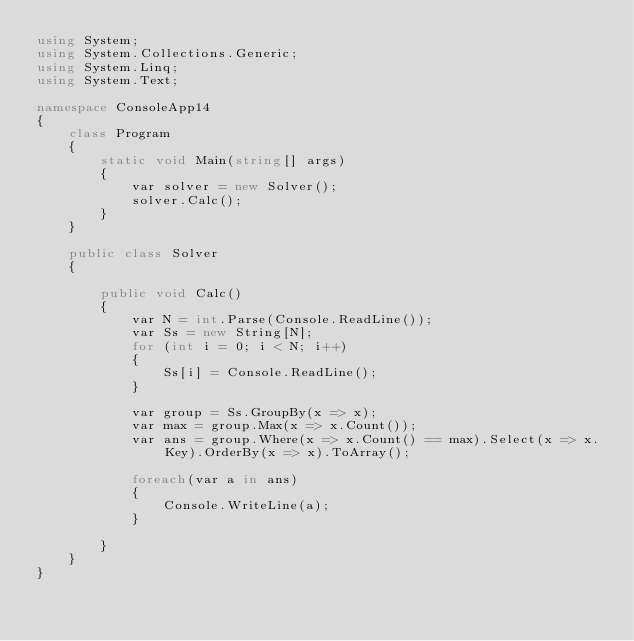<code> <loc_0><loc_0><loc_500><loc_500><_C#_>using System;
using System.Collections.Generic;
using System.Linq;
using System.Text;

namespace ConsoleApp14
{
    class Program
    {
        static void Main(string[] args)
        {
            var solver = new Solver();
            solver.Calc();
        }
    }

    public class Solver
    {

        public void Calc()
        {
            var N = int.Parse(Console.ReadLine());
            var Ss = new String[N];
            for (int i = 0; i < N; i++)
            {
                Ss[i] = Console.ReadLine();
            }

            var group = Ss.GroupBy(x => x);
            var max = group.Max(x => x.Count());
            var ans = group.Where(x => x.Count() == max).Select(x => x.Key).OrderBy(x => x).ToArray();

            foreach(var a in ans)
            {
                Console.WriteLine(a);
            }

        }
    }
}</code> 